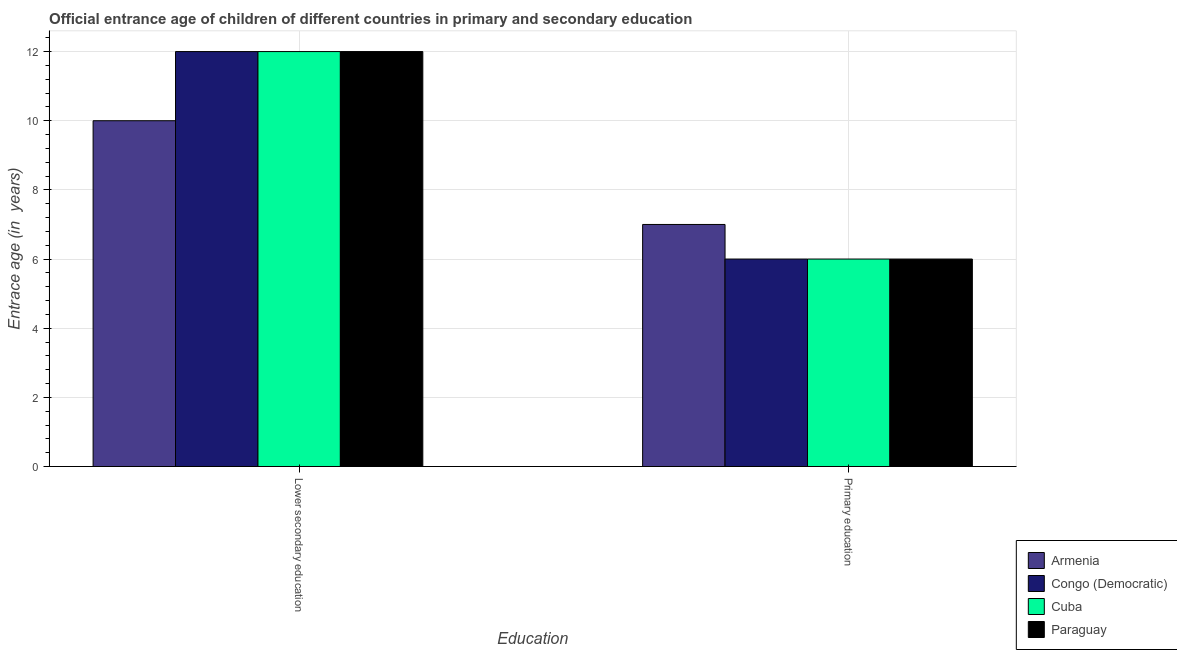How many different coloured bars are there?
Provide a short and direct response. 4. How many groups of bars are there?
Keep it short and to the point. 2. Are the number of bars on each tick of the X-axis equal?
Offer a very short reply. Yes. What is the label of the 2nd group of bars from the left?
Your answer should be very brief. Primary education. Across all countries, what is the maximum entrance age of chiildren in primary education?
Keep it short and to the point. 7. Across all countries, what is the minimum entrance age of children in lower secondary education?
Your answer should be compact. 10. In which country was the entrance age of chiildren in primary education maximum?
Your answer should be compact. Armenia. In which country was the entrance age of chiildren in primary education minimum?
Provide a short and direct response. Congo (Democratic). What is the total entrance age of chiildren in primary education in the graph?
Give a very brief answer. 25. What is the difference between the entrance age of chiildren in primary education in Armenia and the entrance age of children in lower secondary education in Paraguay?
Make the answer very short. -5. What is the average entrance age of chiildren in primary education per country?
Give a very brief answer. 6.25. What is the difference between the entrance age of children in lower secondary education and entrance age of chiildren in primary education in Armenia?
Make the answer very short. 3. What is the ratio of the entrance age of chiildren in primary education in Paraguay to that in Armenia?
Ensure brevity in your answer.  0.86. Is the entrance age of children in lower secondary education in Congo (Democratic) less than that in Paraguay?
Your answer should be very brief. No. What does the 3rd bar from the left in Lower secondary education represents?
Ensure brevity in your answer.  Cuba. What does the 1st bar from the right in Lower secondary education represents?
Offer a terse response. Paraguay. Are all the bars in the graph horizontal?
Your answer should be compact. No. Are the values on the major ticks of Y-axis written in scientific E-notation?
Offer a very short reply. No. Does the graph contain grids?
Your answer should be compact. Yes. What is the title of the graph?
Ensure brevity in your answer.  Official entrance age of children of different countries in primary and secondary education. What is the label or title of the X-axis?
Provide a short and direct response. Education. What is the label or title of the Y-axis?
Provide a short and direct response. Entrace age (in  years). Across all Education, what is the maximum Entrace age (in  years) of Armenia?
Give a very brief answer. 10. Across all Education, what is the minimum Entrace age (in  years) in Congo (Democratic)?
Offer a terse response. 6. Across all Education, what is the minimum Entrace age (in  years) in Cuba?
Make the answer very short. 6. Across all Education, what is the minimum Entrace age (in  years) in Paraguay?
Your answer should be compact. 6. What is the total Entrace age (in  years) of Armenia in the graph?
Ensure brevity in your answer.  17. What is the total Entrace age (in  years) of Cuba in the graph?
Provide a succinct answer. 18. What is the difference between the Entrace age (in  years) in Armenia in Lower secondary education and that in Primary education?
Keep it short and to the point. 3. What is the difference between the Entrace age (in  years) of Congo (Democratic) in Lower secondary education and that in Primary education?
Keep it short and to the point. 6. What is the difference between the Entrace age (in  years) in Paraguay in Lower secondary education and that in Primary education?
Ensure brevity in your answer.  6. What is the difference between the Entrace age (in  years) in Armenia in Lower secondary education and the Entrace age (in  years) in Congo (Democratic) in Primary education?
Offer a terse response. 4. What is the difference between the Entrace age (in  years) of Armenia in Lower secondary education and the Entrace age (in  years) of Paraguay in Primary education?
Provide a short and direct response. 4. What is the difference between the Entrace age (in  years) of Congo (Democratic) in Lower secondary education and the Entrace age (in  years) of Cuba in Primary education?
Provide a short and direct response. 6. What is the difference between the Entrace age (in  years) of Cuba in Lower secondary education and the Entrace age (in  years) of Paraguay in Primary education?
Make the answer very short. 6. What is the average Entrace age (in  years) of Congo (Democratic) per Education?
Provide a short and direct response. 9. What is the average Entrace age (in  years) in Cuba per Education?
Give a very brief answer. 9. What is the average Entrace age (in  years) of Paraguay per Education?
Keep it short and to the point. 9. What is the difference between the Entrace age (in  years) of Armenia and Entrace age (in  years) of Congo (Democratic) in Lower secondary education?
Ensure brevity in your answer.  -2. What is the difference between the Entrace age (in  years) of Armenia and Entrace age (in  years) of Paraguay in Lower secondary education?
Offer a terse response. -2. What is the difference between the Entrace age (in  years) in Congo (Democratic) and Entrace age (in  years) in Cuba in Lower secondary education?
Offer a very short reply. 0. What is the difference between the Entrace age (in  years) in Armenia and Entrace age (in  years) in Paraguay in Primary education?
Keep it short and to the point. 1. What is the difference between the Entrace age (in  years) of Congo (Democratic) and Entrace age (in  years) of Cuba in Primary education?
Your answer should be very brief. 0. What is the ratio of the Entrace age (in  years) of Armenia in Lower secondary education to that in Primary education?
Provide a succinct answer. 1.43. What is the ratio of the Entrace age (in  years) in Congo (Democratic) in Lower secondary education to that in Primary education?
Offer a terse response. 2. 